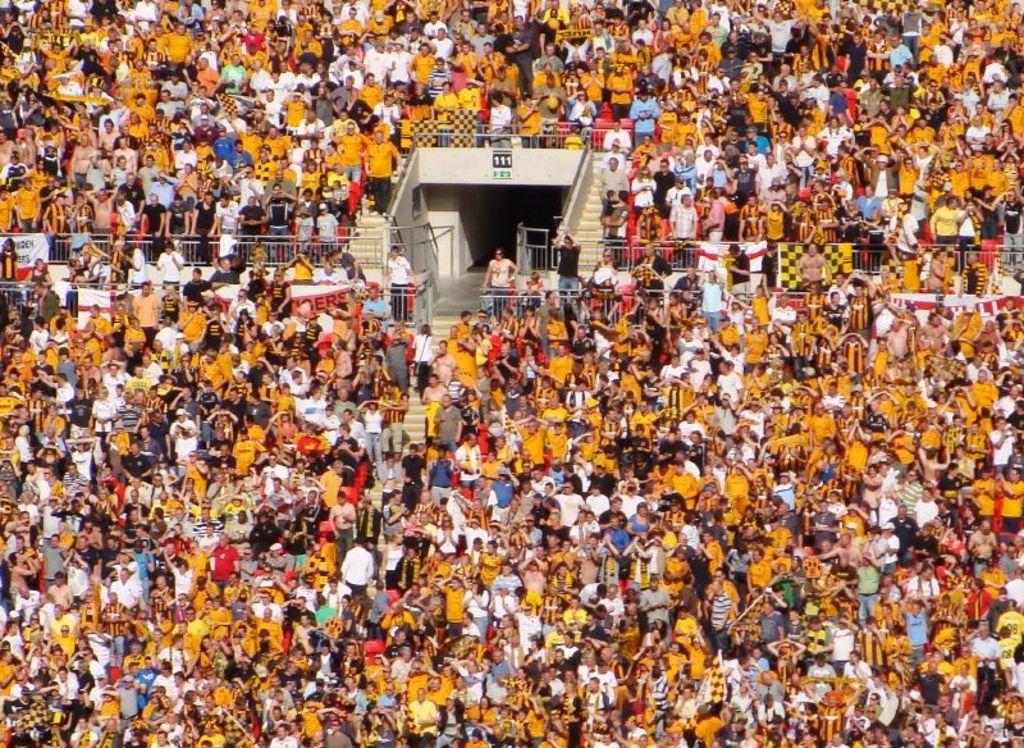What can be seen in the image involving multiple individuals? There is a group of people in the image. What type of furniture is present in the image? There are chairs in the image. Are there any architectural features visible in the image? Yes, there are stairs in the image. What type of decorations or signs are present in the image? There are banners in the image. What is the tendency of the duck in the image? There is no duck present in the image, so it is not possible to determine its tendency. How many chairs are present in the image? The number of chairs in the image cannot be determined from the provided facts, as it only states that there are chairs present. 